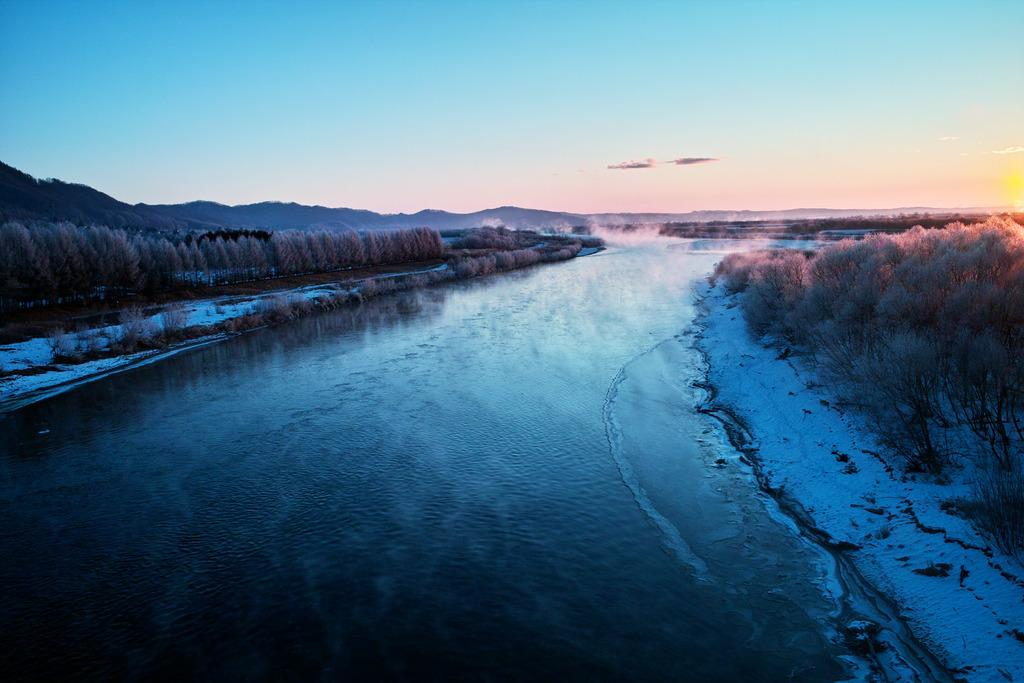What body of water is present in the image? There is a river in the image. How is the land around the river affected by the weather? The land on either side of the river is covered with snow. Are there any plants visible in the image? Yes, there are trees beside the snow. What type of chin can be seen on the clover in the image? There is no clover present in the image, and therefore no chin can be seen. 